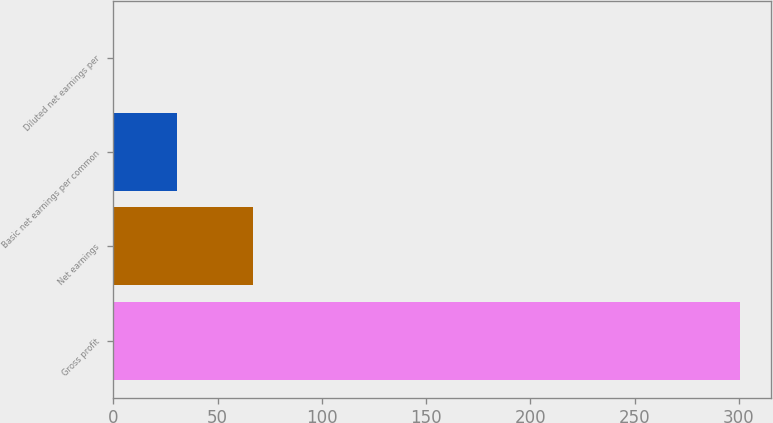<chart> <loc_0><loc_0><loc_500><loc_500><bar_chart><fcel>Gross profit<fcel>Net earnings<fcel>Basic net earnings per common<fcel>Diluted net earnings per<nl><fcel>300.5<fcel>67<fcel>30.39<fcel>0.38<nl></chart> 